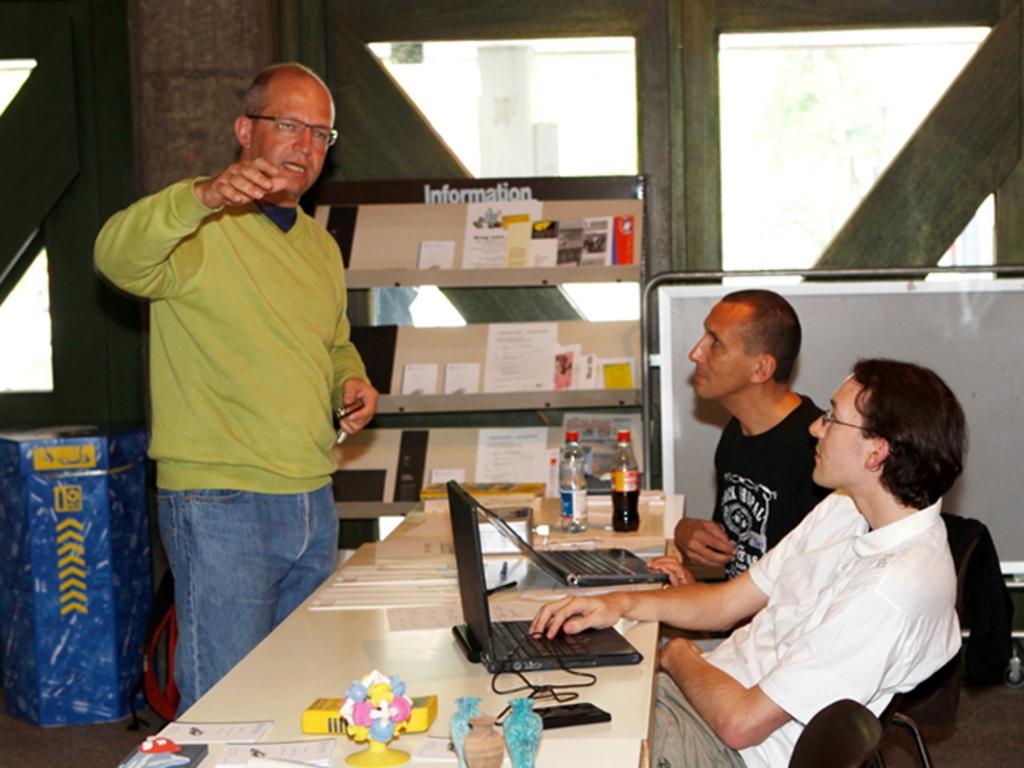Can you describe this image briefly? In this picture we can see man standing wore sweater, spectacle talking and in front of him there is a table and on table we can see bottles, laptops, wires, toys, papers and beside to this table we have two persons sitting on chair and looking at him and in the background we can see racks, window, box. 